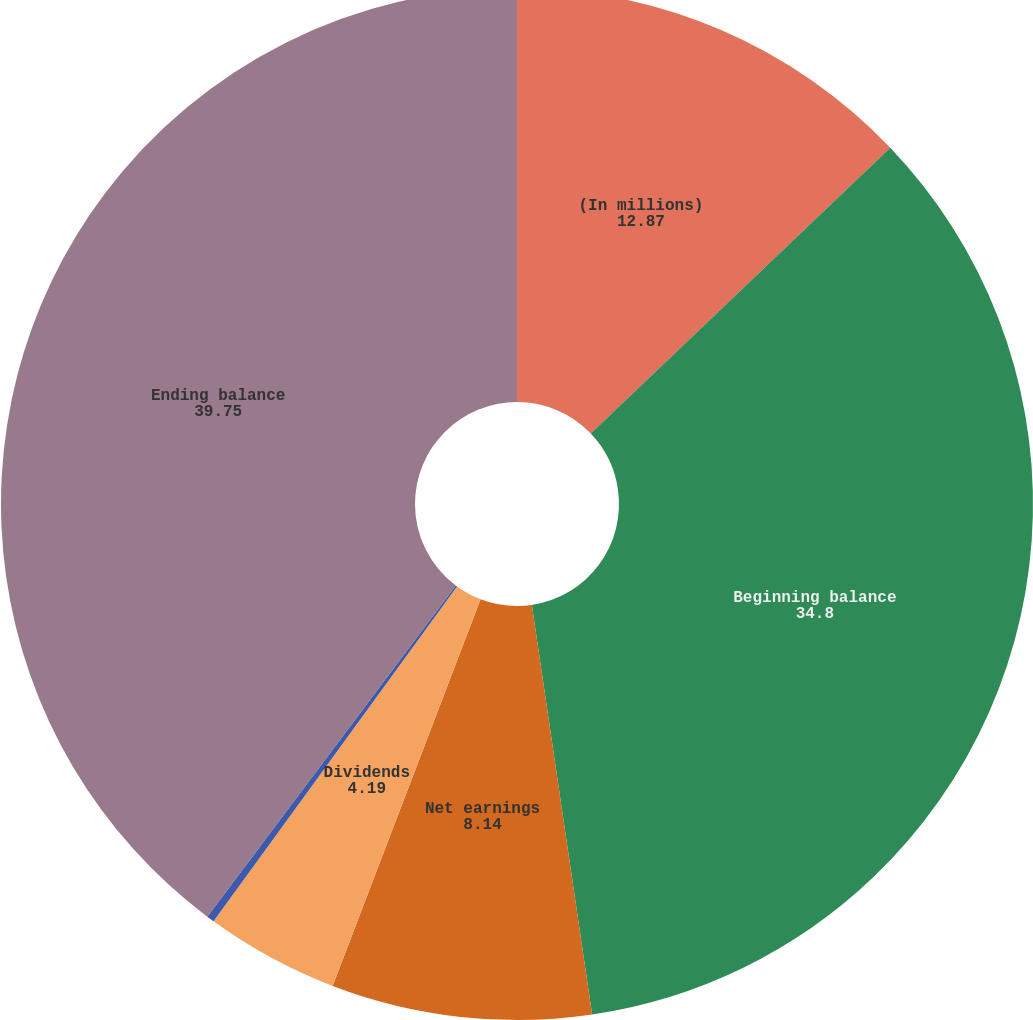Convert chart. <chart><loc_0><loc_0><loc_500><loc_500><pie_chart><fcel>(In millions)<fcel>Beginning balance<fcel>Net earnings<fcel>Dividends<fcel>Other (including AOCI) (c)<fcel>Ending balance<nl><fcel>12.87%<fcel>34.8%<fcel>8.14%<fcel>4.19%<fcel>0.24%<fcel>39.75%<nl></chart> 